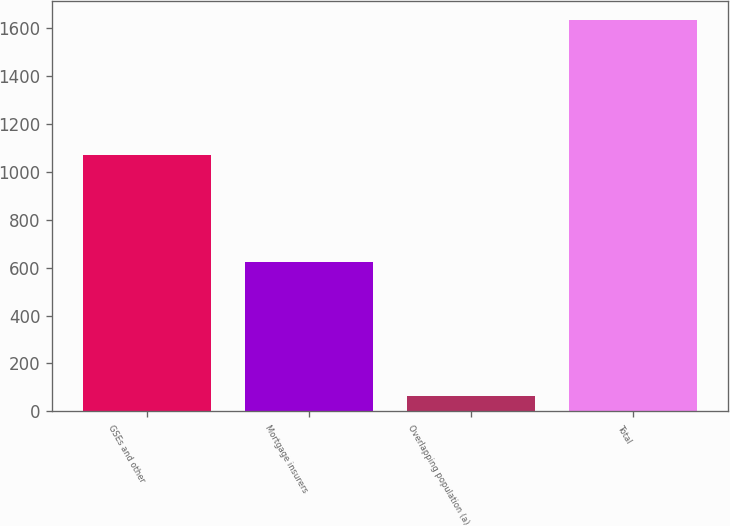<chart> <loc_0><loc_0><loc_500><loc_500><bar_chart><fcel>GSEs and other<fcel>Mortgage insurers<fcel>Overlapping population (a)<fcel>Total<nl><fcel>1071<fcel>624<fcel>63<fcel>1632<nl></chart> 